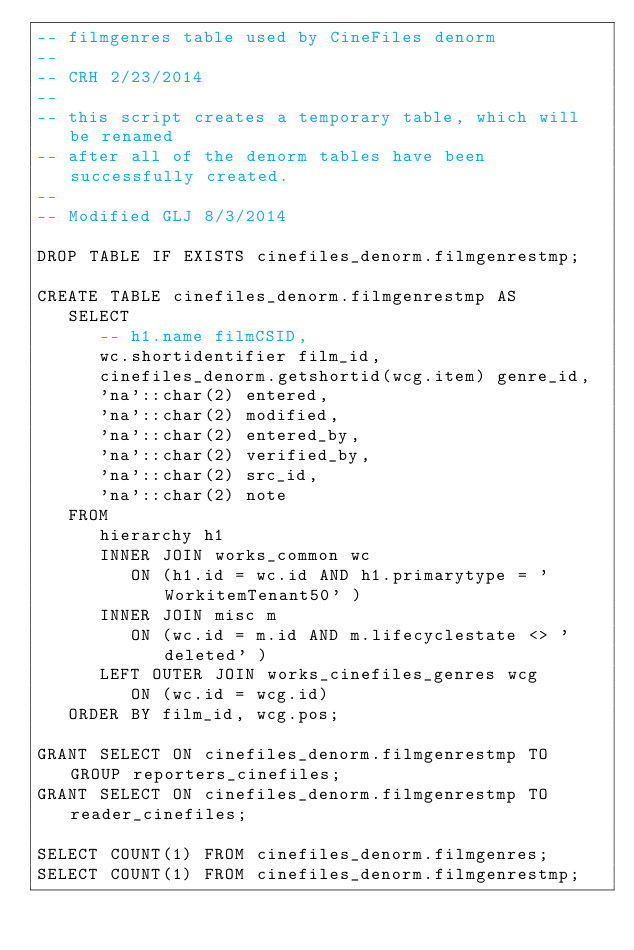Convert code to text. <code><loc_0><loc_0><loc_500><loc_500><_SQL_>-- filmgenres table used by CineFiles denorm
--
-- CRH 2/23/2014
--
-- this script creates a temporary table, which will be renamed
-- after all of the denorm tables have been successfully created.
--
-- Modified GLJ 8/3/2014

DROP TABLE IF EXISTS cinefiles_denorm.filmgenrestmp;

CREATE TABLE cinefiles_denorm.filmgenrestmp AS
   SELECT
      -- h1.name filmCSID,
      wc.shortidentifier film_id,
      cinefiles_denorm.getshortid(wcg.item) genre_id,
      'na'::char(2) entered,
      'na'::char(2) modified,
      'na'::char(2) entered_by,
      'na'::char(2) verified_by,
      'na'::char(2) src_id,
      'na'::char(2) note
   FROM
      hierarchy h1
      INNER JOIN works_common wc
         ON (h1.id = wc.id AND h1.primarytype = 'WorkitemTenant50' )
      INNER JOIN misc m
         ON (wc.id = m.id AND m.lifecyclestate <> 'deleted' )
      LEFT OUTER JOIN works_cinefiles_genres wcg
         ON (wc.id = wcg.id)
   ORDER BY film_id, wcg.pos;

GRANT SELECT ON cinefiles_denorm.filmgenrestmp TO GROUP reporters_cinefiles;
GRANT SELECT ON cinefiles_denorm.filmgenrestmp TO reader_cinefiles;

SELECT COUNT(1) FROM cinefiles_denorm.filmgenres;
SELECT COUNT(1) FROM cinefiles_denorm.filmgenrestmp;

</code> 